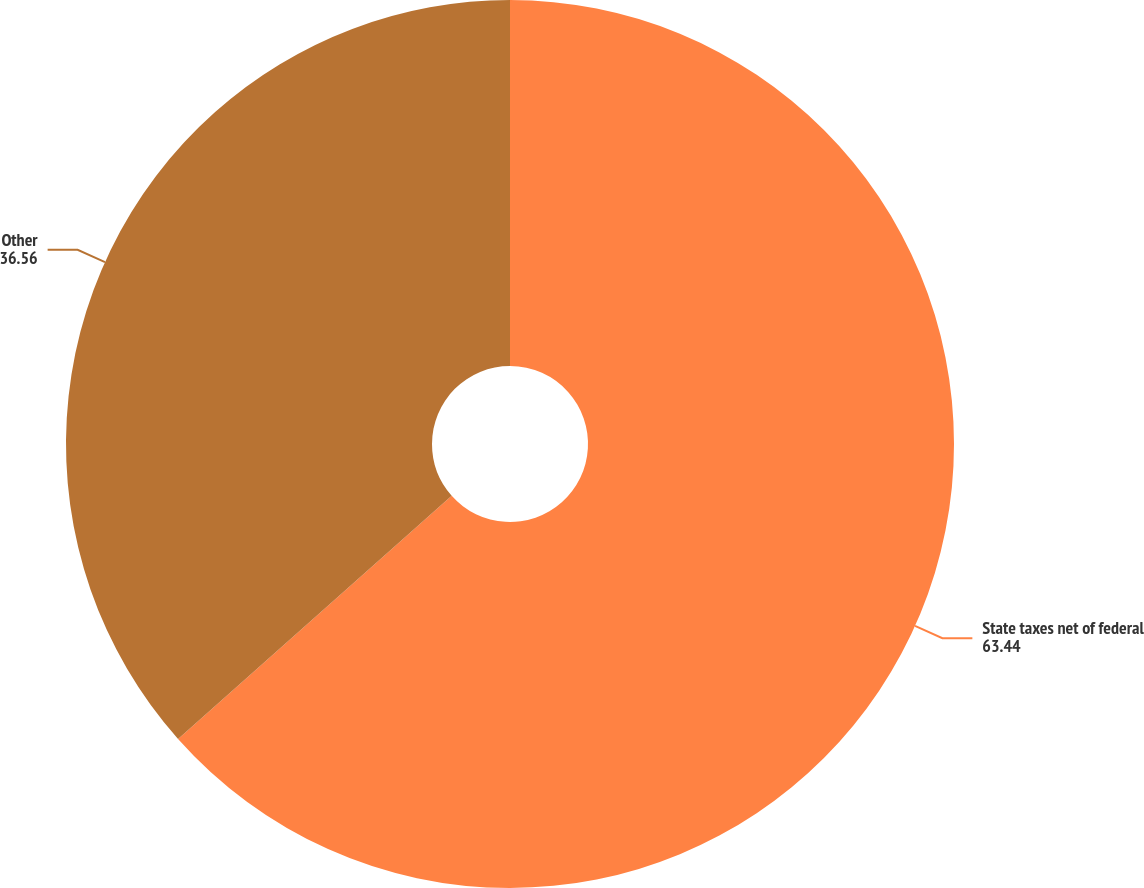Convert chart. <chart><loc_0><loc_0><loc_500><loc_500><pie_chart><fcel>State taxes net of federal<fcel>Other<nl><fcel>63.44%<fcel>36.56%<nl></chart> 